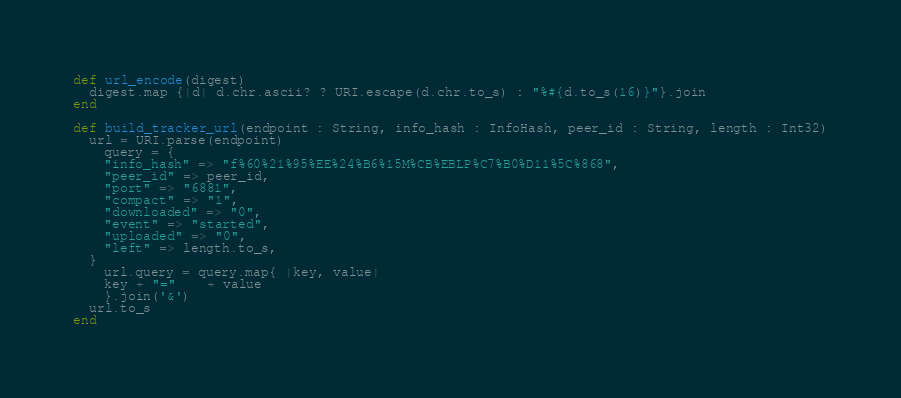<code> <loc_0><loc_0><loc_500><loc_500><_Crystal_>def url_encode(digest)
  digest.map {|d| d.chr.ascii? ? URI.escape(d.chr.to_s) : "%#{d.to_s(16)}"}.join
end

def build_tracker_url(endpoint : String, info_hash : InfoHash, peer_id : String, length : Int32)
  url = URI.parse(endpoint)
	query = {
    "info_hash" => "f%60%21%95%EE%24%B6%15M%CB%EBLP%C7%B0%D11%5C%868",
    "peer_id" => peer_id,
    "port" => "6881",
    "compact" => "1",
    "downloaded" => "0",
    "event" => "started",
    "uploaded" => "0",
    "left" => length.to_s,
  }
	url.query = query.map{ |key, value|
    key + "="	+ value
    }.join('&')
  url.to_s
end
</code> 